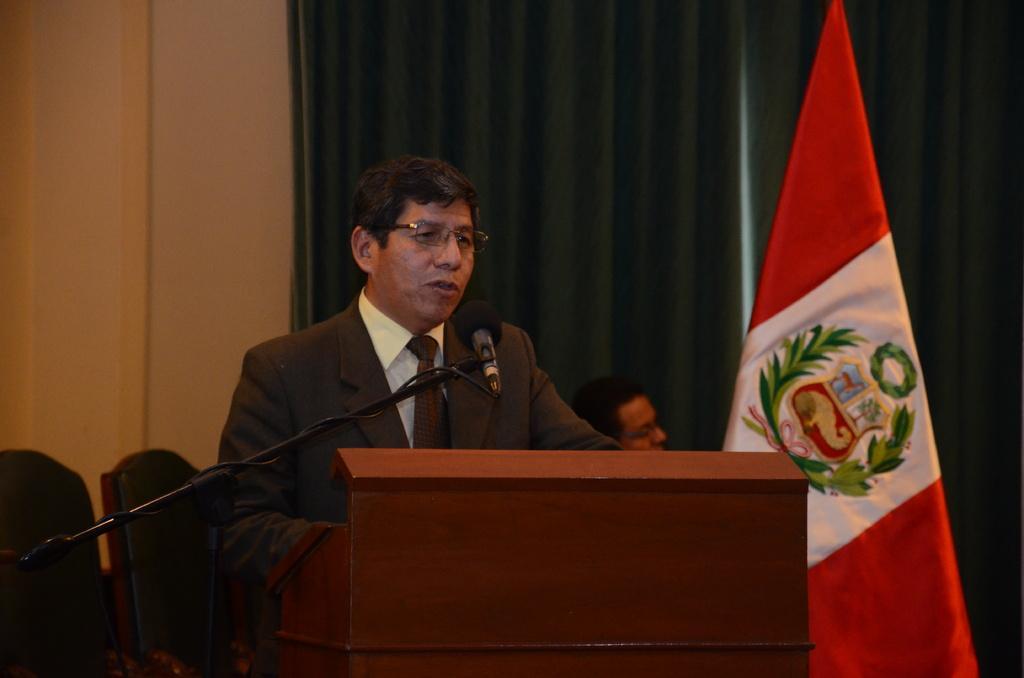In one or two sentences, can you explain what this image depicts? In this image I can see a podium, flag, mike , person standing in front of podium , backside of person I can see the wall, curtain , person chairs visible. 